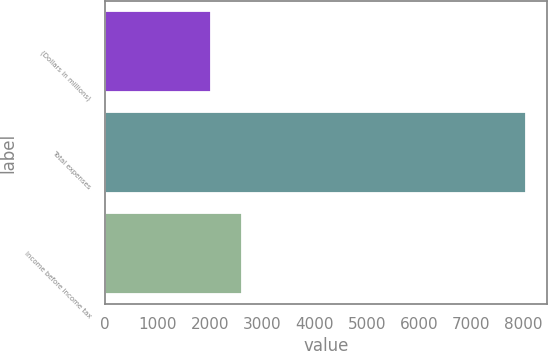Convert chart. <chart><loc_0><loc_0><loc_500><loc_500><bar_chart><fcel>(Dollars in millions)<fcel>Total expenses<fcel>Income before income tax<nl><fcel>2015<fcel>8050<fcel>2618.5<nl></chart> 